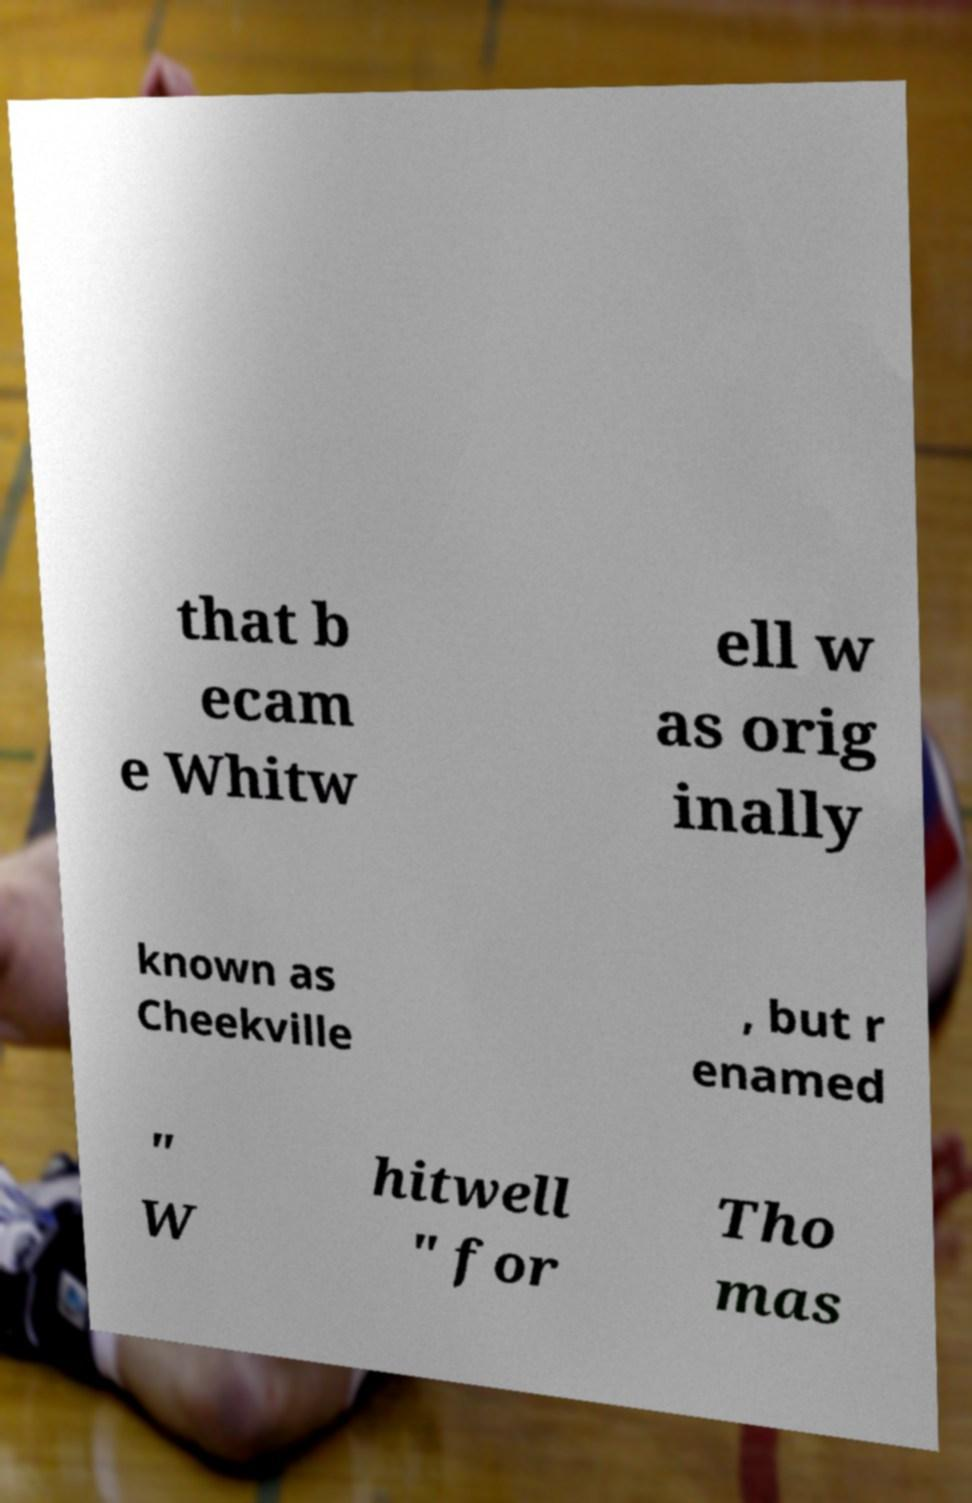What messages or text are displayed in this image? I need them in a readable, typed format. that b ecam e Whitw ell w as orig inally known as Cheekville , but r enamed " W hitwell " for Tho mas 